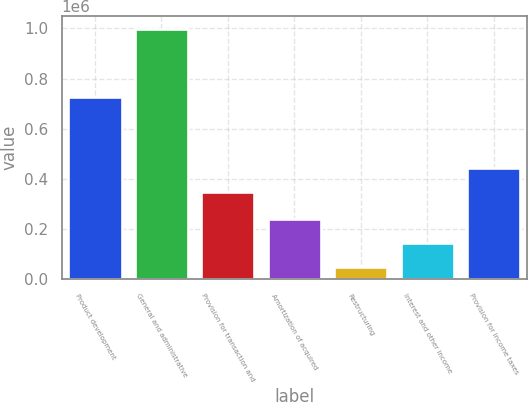Convert chart. <chart><loc_0><loc_0><loc_500><loc_500><bar_chart><fcel>Product development<fcel>General and administrative<fcel>Provision for transaction and<fcel>Amortization of acquired<fcel>Restructuring<fcel>Interest and other income<fcel>Provision for income taxes<nl><fcel>725600<fcel>998871<fcel>347453<fcel>239069<fcel>49119<fcel>144094<fcel>442428<nl></chart> 